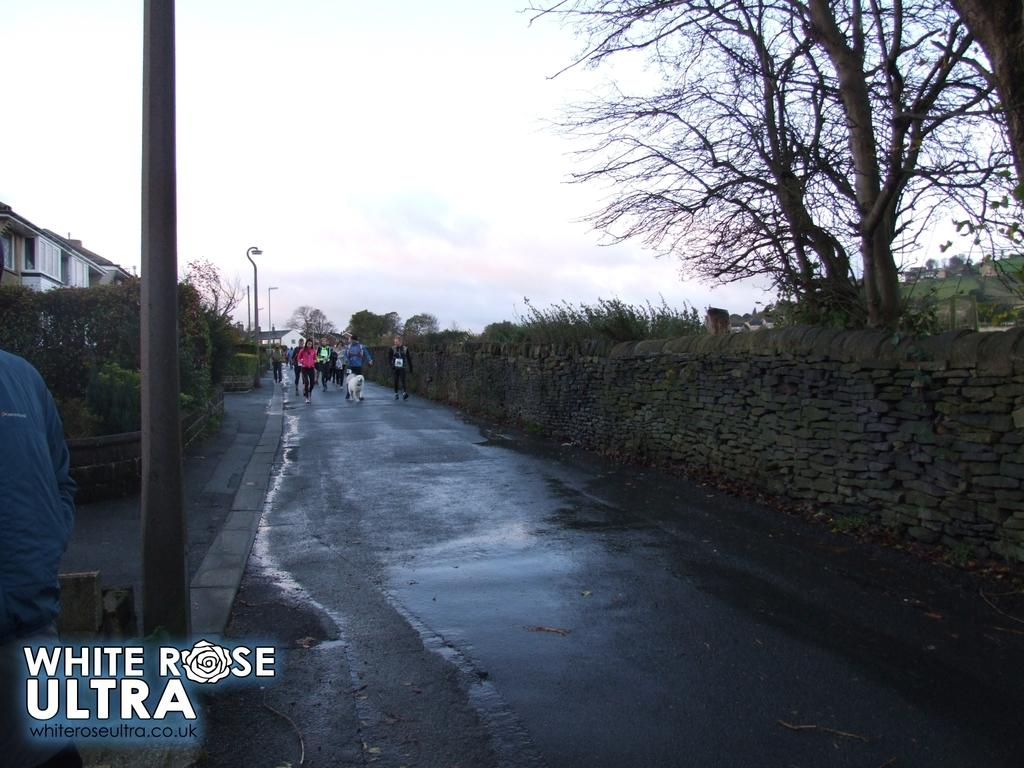<image>
Write a terse but informative summary of the picture. A group of people walking down a path with a white rose ultra label. 